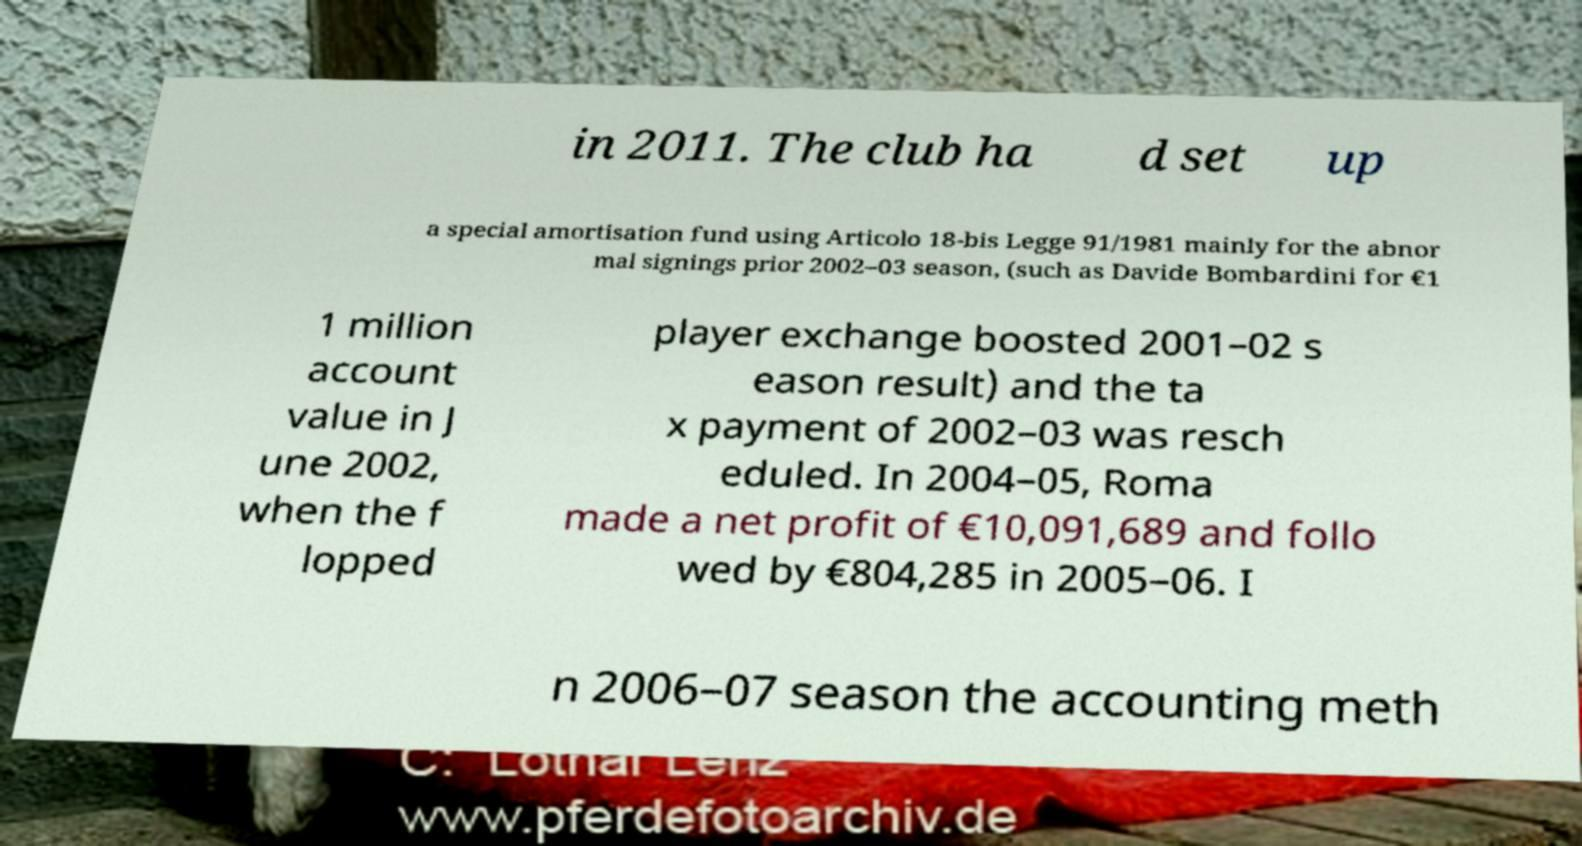Could you assist in decoding the text presented in this image and type it out clearly? in 2011. The club ha d set up a special amortisation fund using Articolo 18-bis Legge 91/1981 mainly for the abnor mal signings prior 2002–03 season, (such as Davide Bombardini for €1 1 million account value in J une 2002, when the f lopped player exchange boosted 2001–02 s eason result) and the ta x payment of 2002–03 was resch eduled. In 2004–05, Roma made a net profit of €10,091,689 and follo wed by €804,285 in 2005–06. I n 2006–07 season the accounting meth 